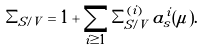Convert formula to latex. <formula><loc_0><loc_0><loc_500><loc_500>\Sigma _ { S / V } = 1 + \sum _ { i \geq 1 } \Sigma _ { S / V } ^ { ( i ) } \, a _ { s } ^ { i } ( \mu ) .</formula> 